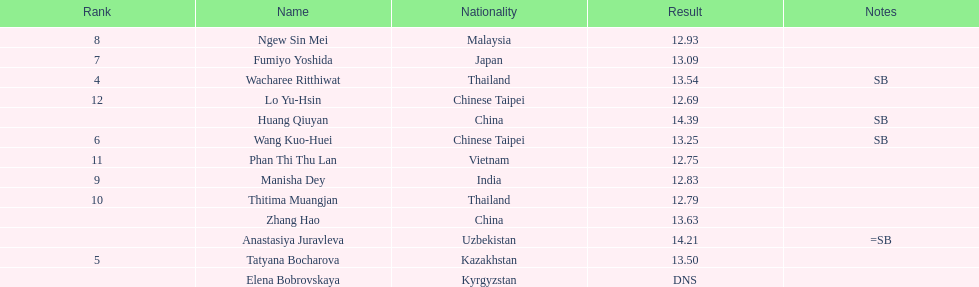What is the number of different nationalities represented by the top 5 athletes? 4. 